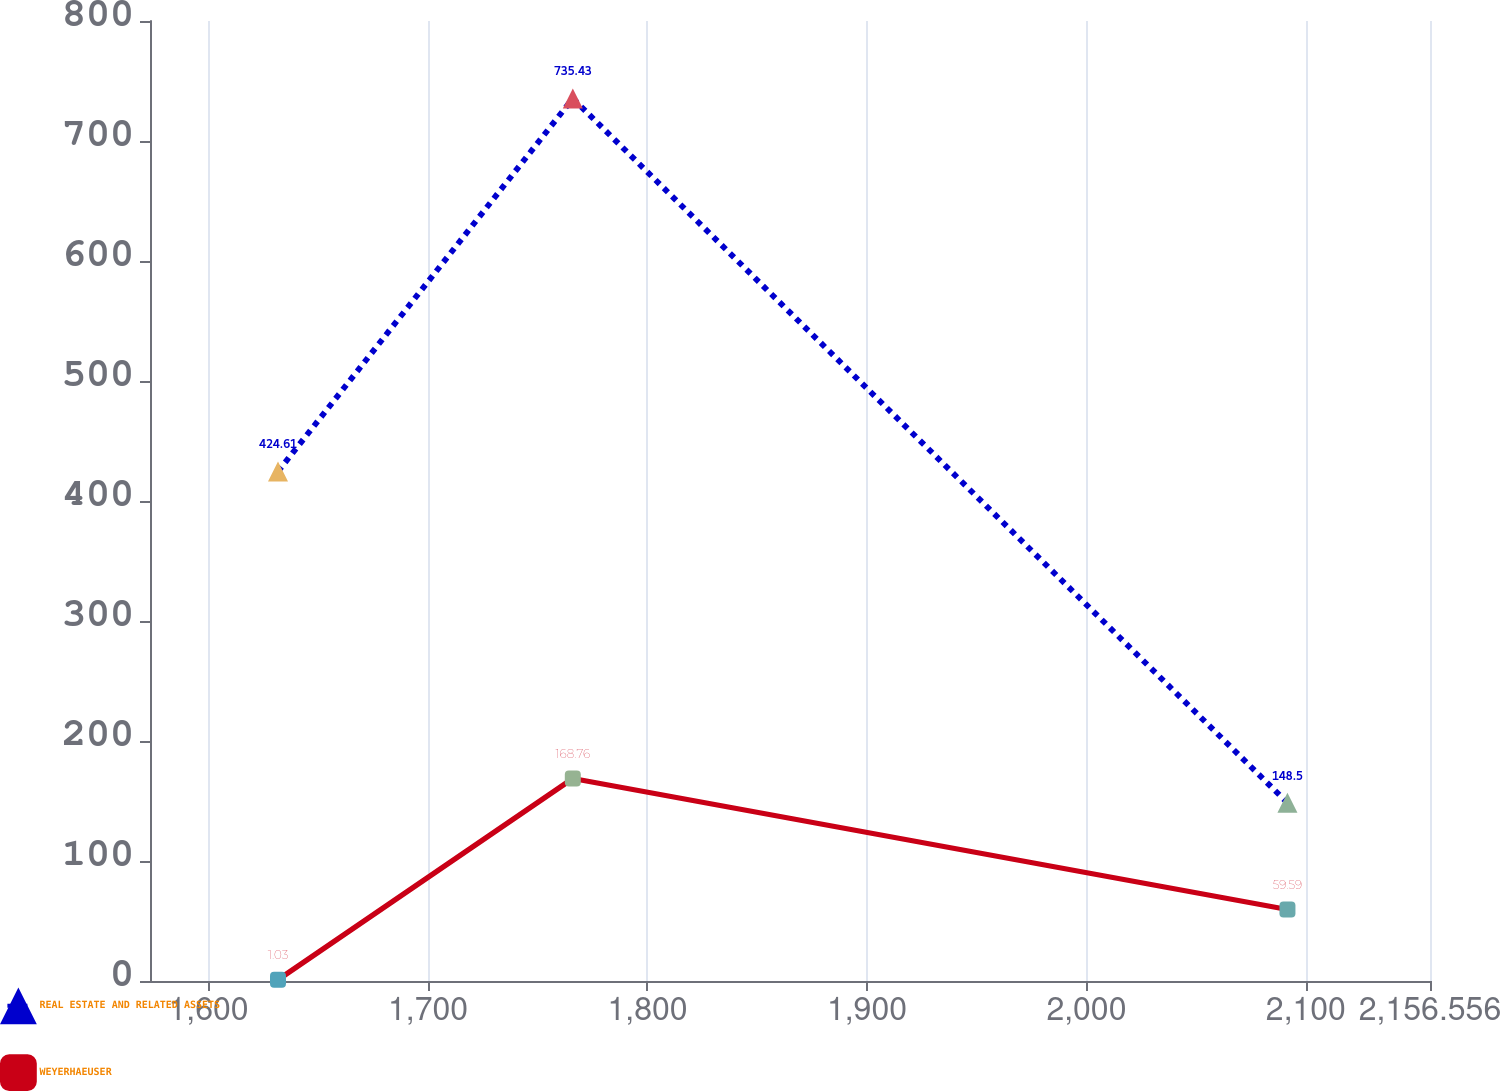<chart> <loc_0><loc_0><loc_500><loc_500><line_chart><ecel><fcel>REAL ESTATE AND RELATED ASSETS<fcel>WEYERHAEUSER<nl><fcel>1631.64<fcel>424.61<fcel>1.03<nl><fcel>1765.97<fcel>735.43<fcel>168.76<nl><fcel>2091.6<fcel>148.5<fcel>59.59<nl><fcel>2160.05<fcel>75.13<fcel>42.37<nl><fcel>2214.88<fcel>1.76<fcel>81.37<nl></chart> 